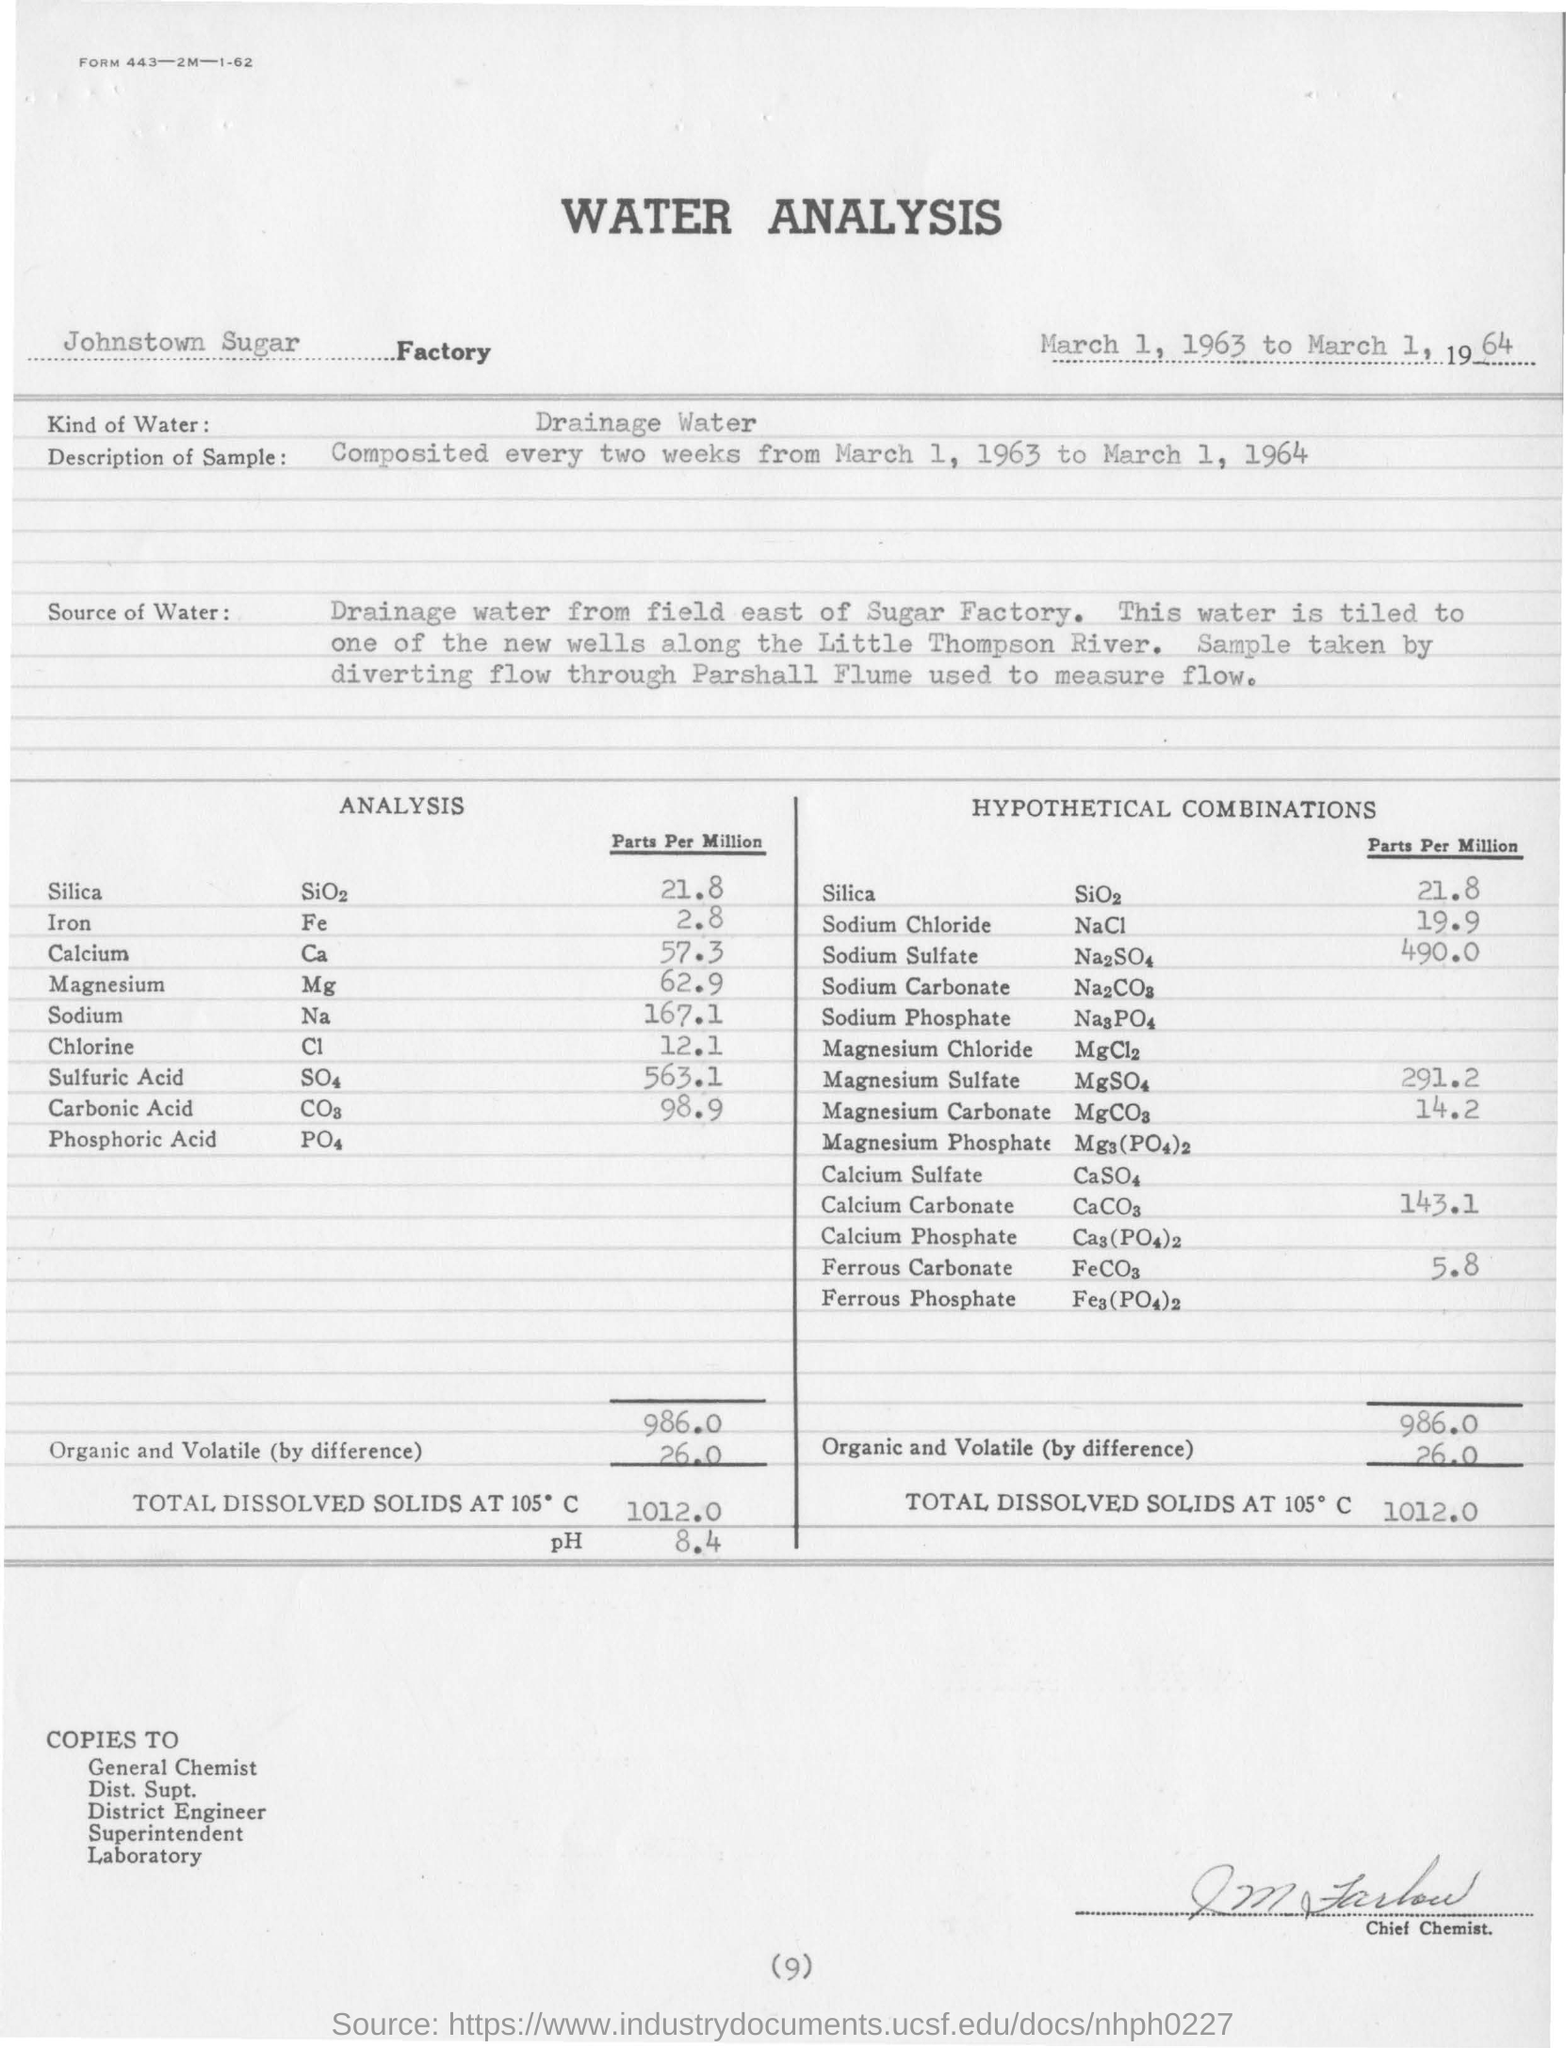Which type of water is used in the analysis?
Provide a short and direct response. Drainage water. In which factory is the analysis done?
Your answer should be compact. Johnstown sugar factory. 